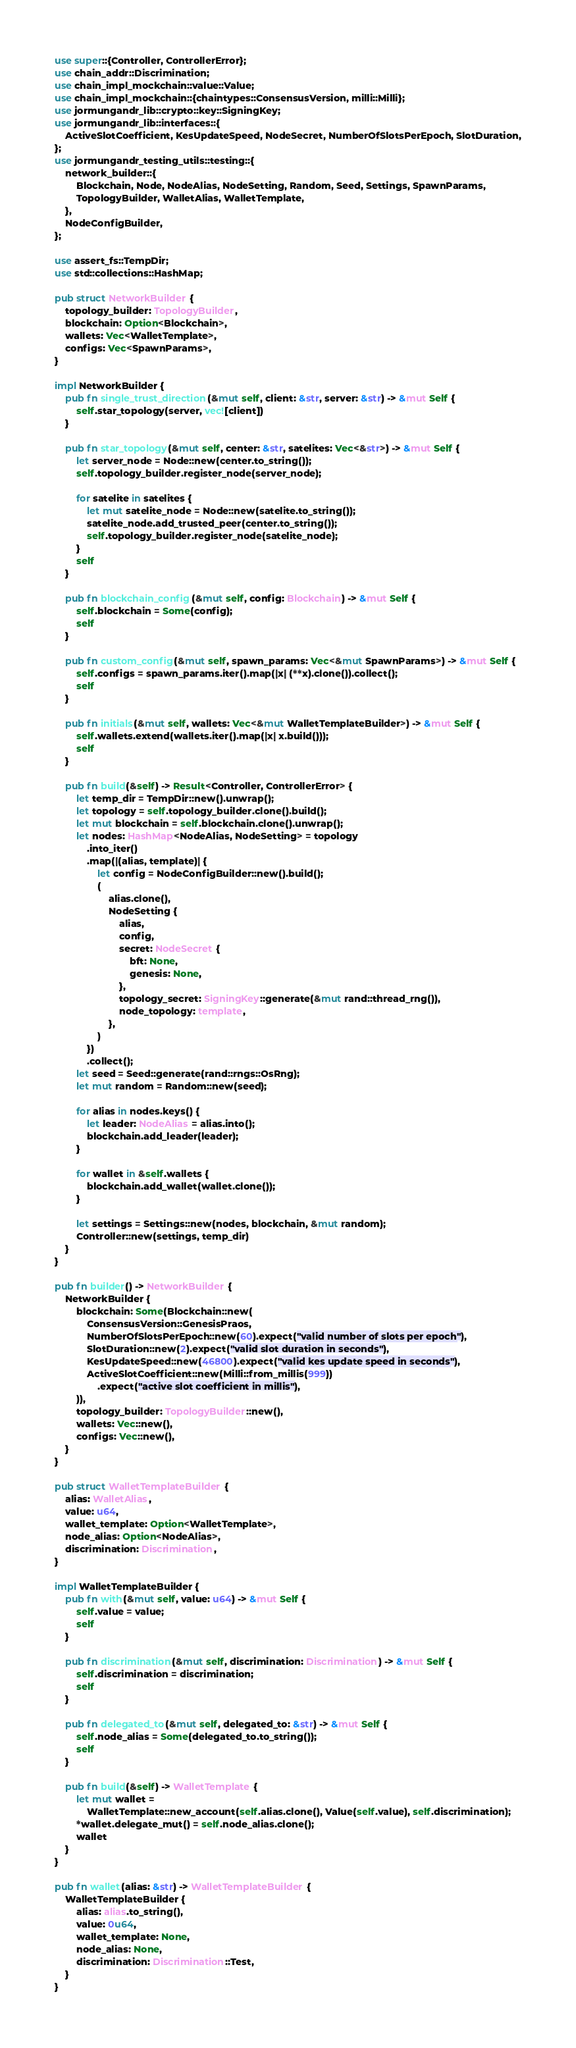<code> <loc_0><loc_0><loc_500><loc_500><_Rust_>use super::{Controller, ControllerError};
use chain_addr::Discrimination;
use chain_impl_mockchain::value::Value;
use chain_impl_mockchain::{chaintypes::ConsensusVersion, milli::Milli};
use jormungandr_lib::crypto::key::SigningKey;
use jormungandr_lib::interfaces::{
    ActiveSlotCoefficient, KesUpdateSpeed, NodeSecret, NumberOfSlotsPerEpoch, SlotDuration,
};
use jormungandr_testing_utils::testing::{
    network_builder::{
        Blockchain, Node, NodeAlias, NodeSetting, Random, Seed, Settings, SpawnParams,
        TopologyBuilder, WalletAlias, WalletTemplate,
    },
    NodeConfigBuilder,
};

use assert_fs::TempDir;
use std::collections::HashMap;

pub struct NetworkBuilder {
    topology_builder: TopologyBuilder,
    blockchain: Option<Blockchain>,
    wallets: Vec<WalletTemplate>,
    configs: Vec<SpawnParams>,
}

impl NetworkBuilder {
    pub fn single_trust_direction(&mut self, client: &str, server: &str) -> &mut Self {
        self.star_topology(server, vec![client])
    }

    pub fn star_topology(&mut self, center: &str, satelites: Vec<&str>) -> &mut Self {
        let server_node = Node::new(center.to_string());
        self.topology_builder.register_node(server_node);

        for satelite in satelites {
            let mut satelite_node = Node::new(satelite.to_string());
            satelite_node.add_trusted_peer(center.to_string());
            self.topology_builder.register_node(satelite_node);
        }
        self
    }

    pub fn blockchain_config(&mut self, config: Blockchain) -> &mut Self {
        self.blockchain = Some(config);
        self
    }

    pub fn custom_config(&mut self, spawn_params: Vec<&mut SpawnParams>) -> &mut Self {
        self.configs = spawn_params.iter().map(|x| (**x).clone()).collect();
        self
    }

    pub fn initials(&mut self, wallets: Vec<&mut WalletTemplateBuilder>) -> &mut Self {
        self.wallets.extend(wallets.iter().map(|x| x.build()));
        self
    }

    pub fn build(&self) -> Result<Controller, ControllerError> {
        let temp_dir = TempDir::new().unwrap();
        let topology = self.topology_builder.clone().build();
        let mut blockchain = self.blockchain.clone().unwrap();
        let nodes: HashMap<NodeAlias, NodeSetting> = topology
            .into_iter()
            .map(|(alias, template)| {
                let config = NodeConfigBuilder::new().build();
                (
                    alias.clone(),
                    NodeSetting {
                        alias,
                        config,
                        secret: NodeSecret {
                            bft: None,
                            genesis: None,
                        },
                        topology_secret: SigningKey::generate(&mut rand::thread_rng()),
                        node_topology: template,
                    },
                )
            })
            .collect();
        let seed = Seed::generate(rand::rngs::OsRng);
        let mut random = Random::new(seed);

        for alias in nodes.keys() {
            let leader: NodeAlias = alias.into();
            blockchain.add_leader(leader);
        }

        for wallet in &self.wallets {
            blockchain.add_wallet(wallet.clone());
        }

        let settings = Settings::new(nodes, blockchain, &mut random);
        Controller::new(settings, temp_dir)
    }
}

pub fn builder() -> NetworkBuilder {
    NetworkBuilder {
        blockchain: Some(Blockchain::new(
            ConsensusVersion::GenesisPraos,
            NumberOfSlotsPerEpoch::new(60).expect("valid number of slots per epoch"),
            SlotDuration::new(2).expect("valid slot duration in seconds"),
            KesUpdateSpeed::new(46800).expect("valid kes update speed in seconds"),
            ActiveSlotCoefficient::new(Milli::from_millis(999))
                .expect("active slot coefficient in millis"),
        )),
        topology_builder: TopologyBuilder::new(),
        wallets: Vec::new(),
        configs: Vec::new(),
    }
}

pub struct WalletTemplateBuilder {
    alias: WalletAlias,
    value: u64,
    wallet_template: Option<WalletTemplate>,
    node_alias: Option<NodeAlias>,
    discrimination: Discrimination,
}

impl WalletTemplateBuilder {
    pub fn with(&mut self, value: u64) -> &mut Self {
        self.value = value;
        self
    }

    pub fn discrimination(&mut self, discrimination: Discrimination) -> &mut Self {
        self.discrimination = discrimination;
        self
    }

    pub fn delegated_to(&mut self, delegated_to: &str) -> &mut Self {
        self.node_alias = Some(delegated_to.to_string());
        self
    }

    pub fn build(&self) -> WalletTemplate {
        let mut wallet =
            WalletTemplate::new_account(self.alias.clone(), Value(self.value), self.discrimination);
        *wallet.delegate_mut() = self.node_alias.clone();
        wallet
    }
}

pub fn wallet(alias: &str) -> WalletTemplateBuilder {
    WalletTemplateBuilder {
        alias: alias.to_string(),
        value: 0u64,
        wallet_template: None,
        node_alias: None,
        discrimination: Discrimination::Test,
    }
}
</code> 